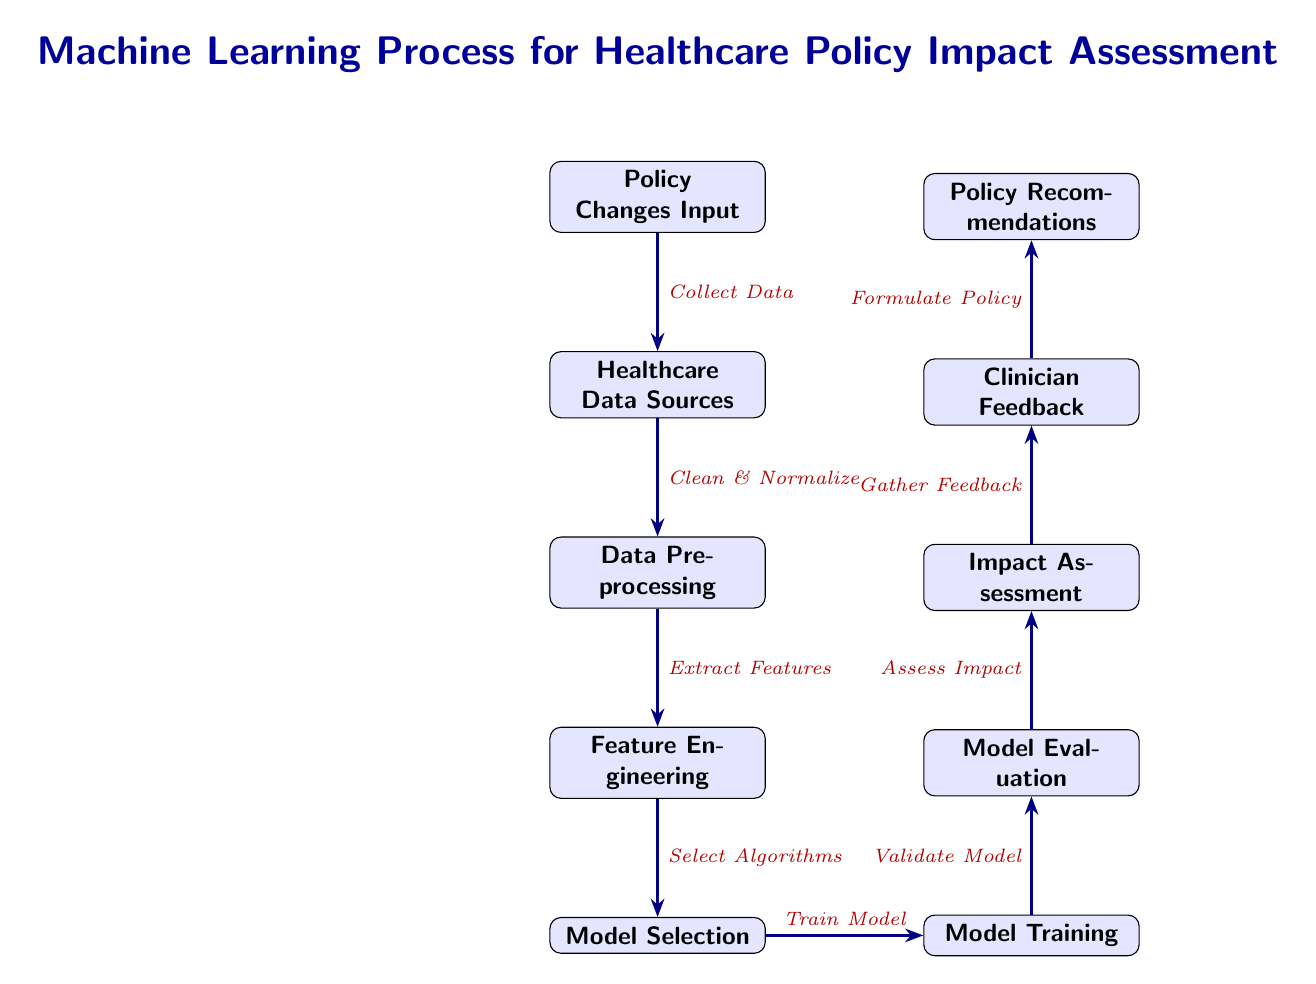What is the first node in the diagram? The first node in the diagram is labeled "Policy Changes Input," which indicates that it is the starting point for the process.
Answer: Policy Changes Input How many nodes are there in total? Counting all the individual boxes in the diagram, there are nine nodes from "Policy Changes Input" to "Policy Recommendations."
Answer: Nine What action is taken after "Model Selection"? The next action taken after "Model Selection" is "Model Training," as indicated by the arrow connecting these two nodes.
Answer: Model Training Which node directly precedes the "Impact Assessment" node? The node directly before "Impact Assessment" is "Model Evaluation," connecting through an arrow that signifies the flow of the process.
Answer: Model Evaluation What feedback is gathered for formulating policy? The feedback gathered is labeled "Clinician Feedback," which is indicated as the input for the "Policy Recommendations" stage.
Answer: Clinician Feedback What is the last step in the process? The last step in the diagram is "Policy Recommendations," which concludes the machine learning process aimed at assessing the impact of policy changes.
Answer: Policy Recommendations What does the arrow between "Data Preprocessing" and "Feature Engineering" indicate? The arrow indicates an action, specifically "Extract Features," which describes what happens as data transitions from preprocessing to feature engineering.
Answer: Extract Features How does the diagram quantify the assessment of policy impact? The diagram indicates this through the "Assess Impact" step following "Model Evaluation," suggesting that impact is quantitatively analyzed based on prior findings.
Answer: Assess Impact What transition occurs after "Gather Feedback"? After "Gather Feedback," the process transitions to "Formulate Policy," showing how feedback influences policy-making steps.
Answer: Formulate Policy 